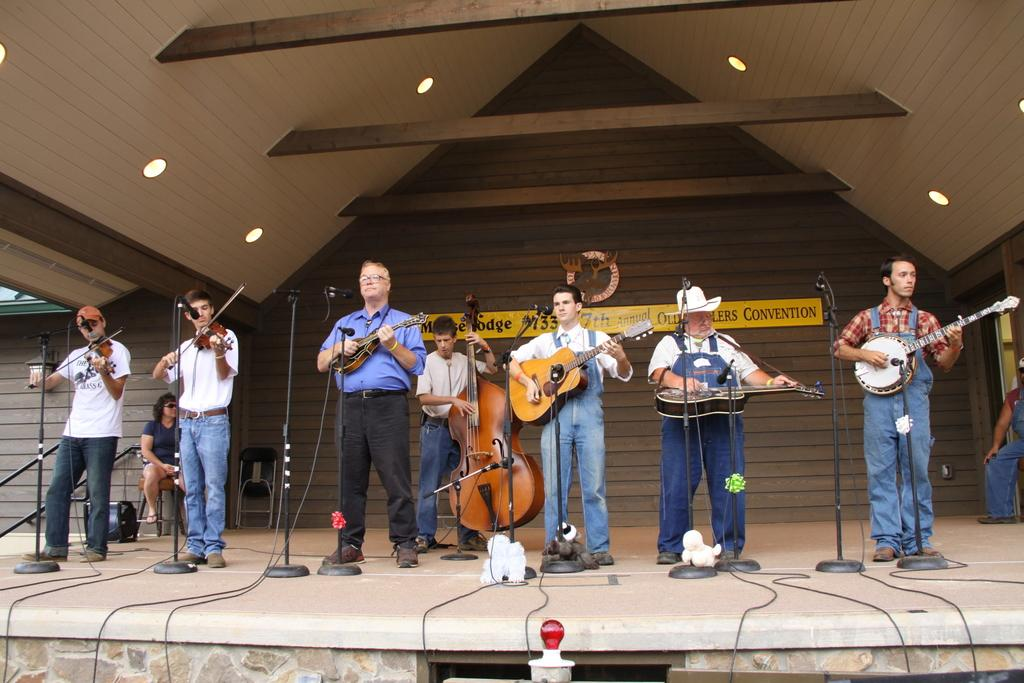What is happening in the image involving a group of people? The people in the image are playing a musical instrument. How are the people positioned in the image? The people are standing in the image. What can be seen in the background of the image? There is a building in the background of the image. How many teeth can be seen in the image? There are no teeth visible in the image, as it features a group of people playing a musical instrument. 